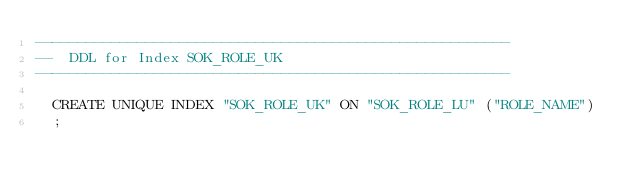Convert code to text. <code><loc_0><loc_0><loc_500><loc_500><_SQL_>--------------------------------------------------------
--  DDL for Index SOK_ROLE_UK
--------------------------------------------------------

  CREATE UNIQUE INDEX "SOK_ROLE_UK" ON "SOK_ROLE_LU" ("ROLE_NAME") 
  ;
</code> 